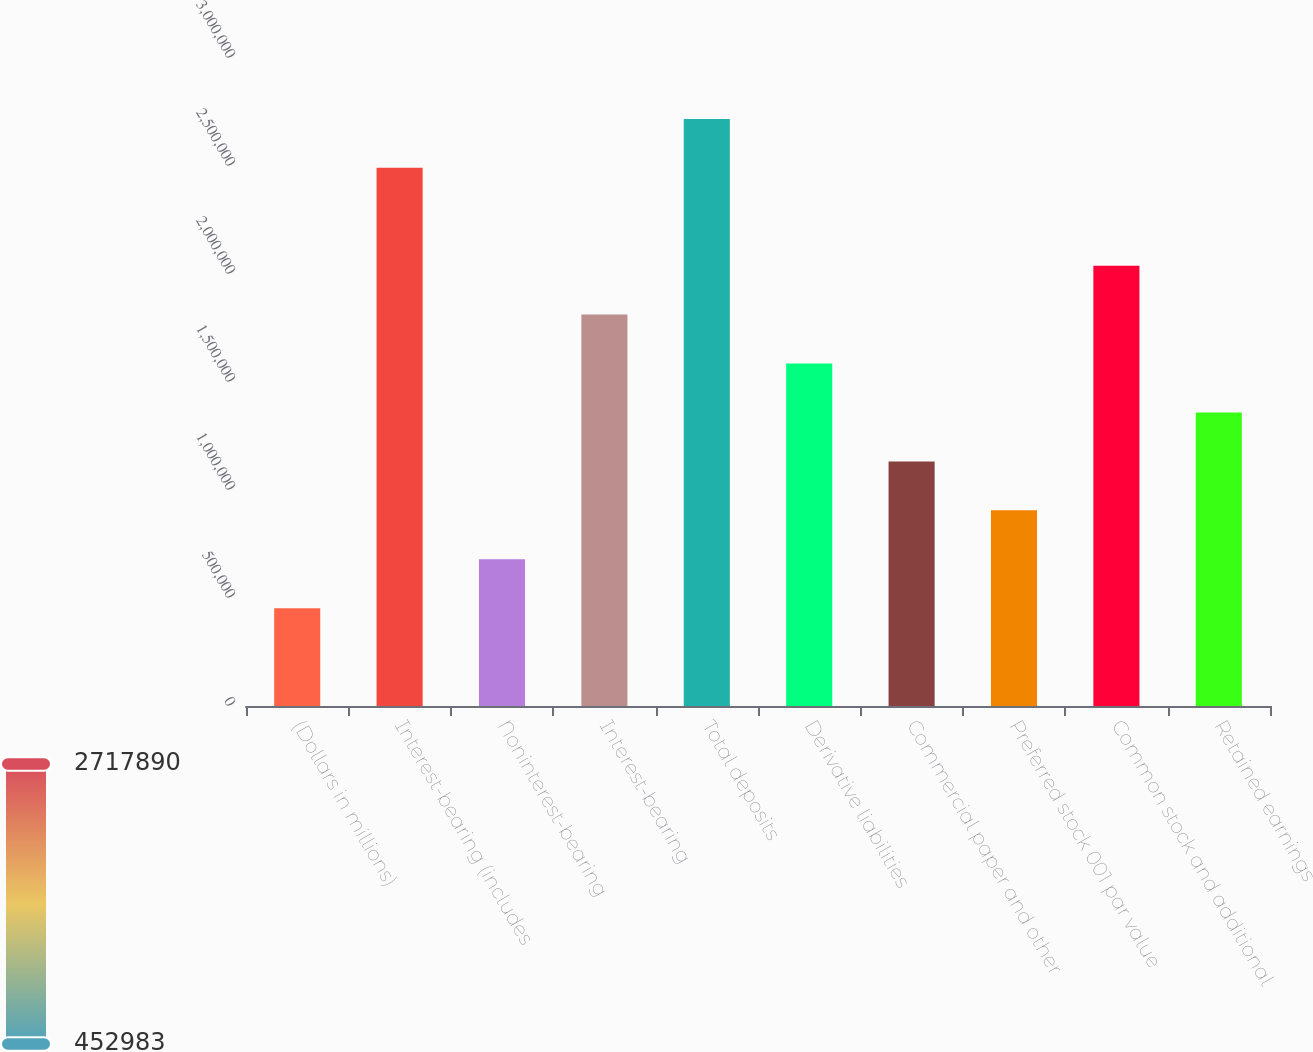Convert chart. <chart><loc_0><loc_0><loc_500><loc_500><bar_chart><fcel>(Dollars in millions)<fcel>Interest-bearing (includes<fcel>Noninterest-bearing<fcel>Interest-bearing<fcel>Total deposits<fcel>Derivative liabilities<fcel>Commercial paper and other<fcel>Preferred stock 001 par value<fcel>Common stock and additional<fcel>Retained earnings<nl><fcel>452983<fcel>2.4914e+06<fcel>679474<fcel>1.81193e+06<fcel>2.71789e+06<fcel>1.58544e+06<fcel>1.13246e+06<fcel>905965<fcel>2.03842e+06<fcel>1.35895e+06<nl></chart> 